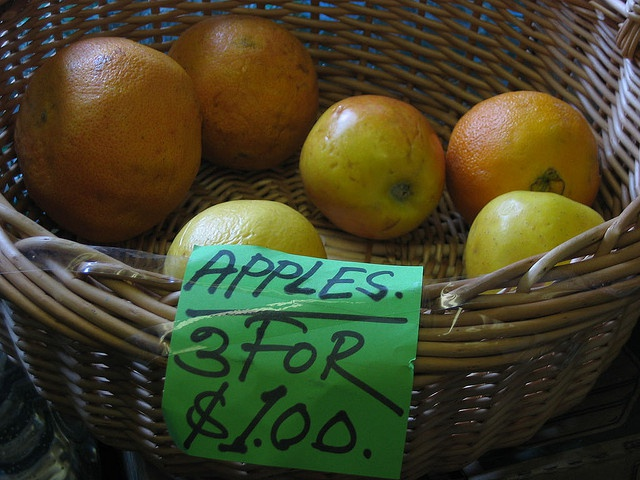Describe the objects in this image and their specific colors. I can see orange in black, maroon, and gray tones, apple in black, olive, and maroon tones, orange in black, maroon, and gray tones, orange in black, olive, and maroon tones, and orange in black, olive, maroon, and tan tones in this image. 